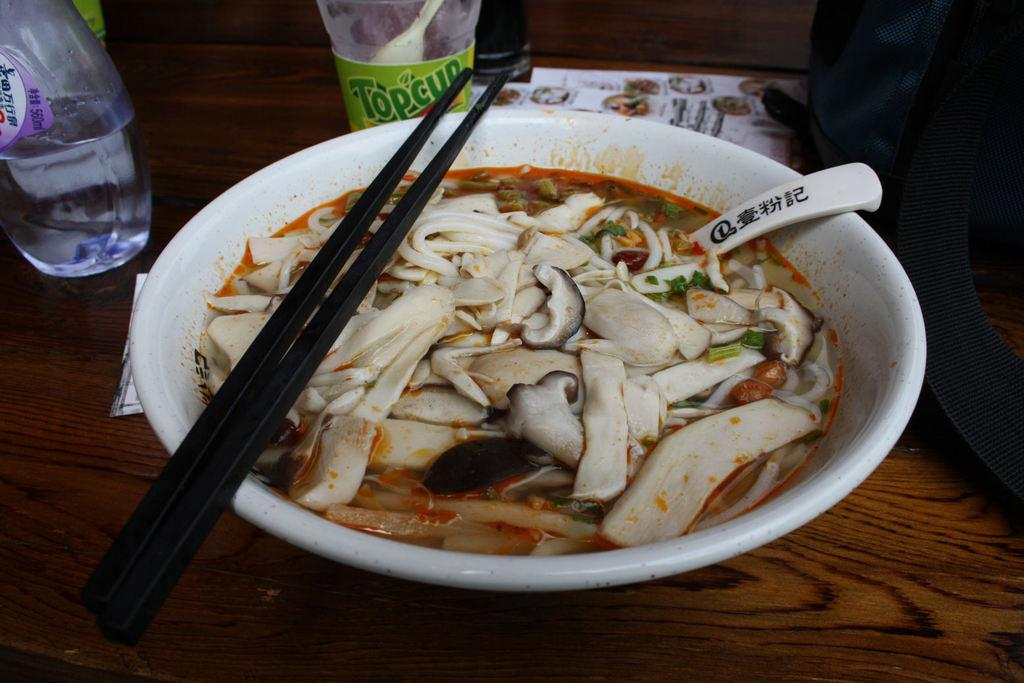<image>
Create a compact narrative representing the image presented. a bowl of food sitting in front of a cup labeled 'top cup' 